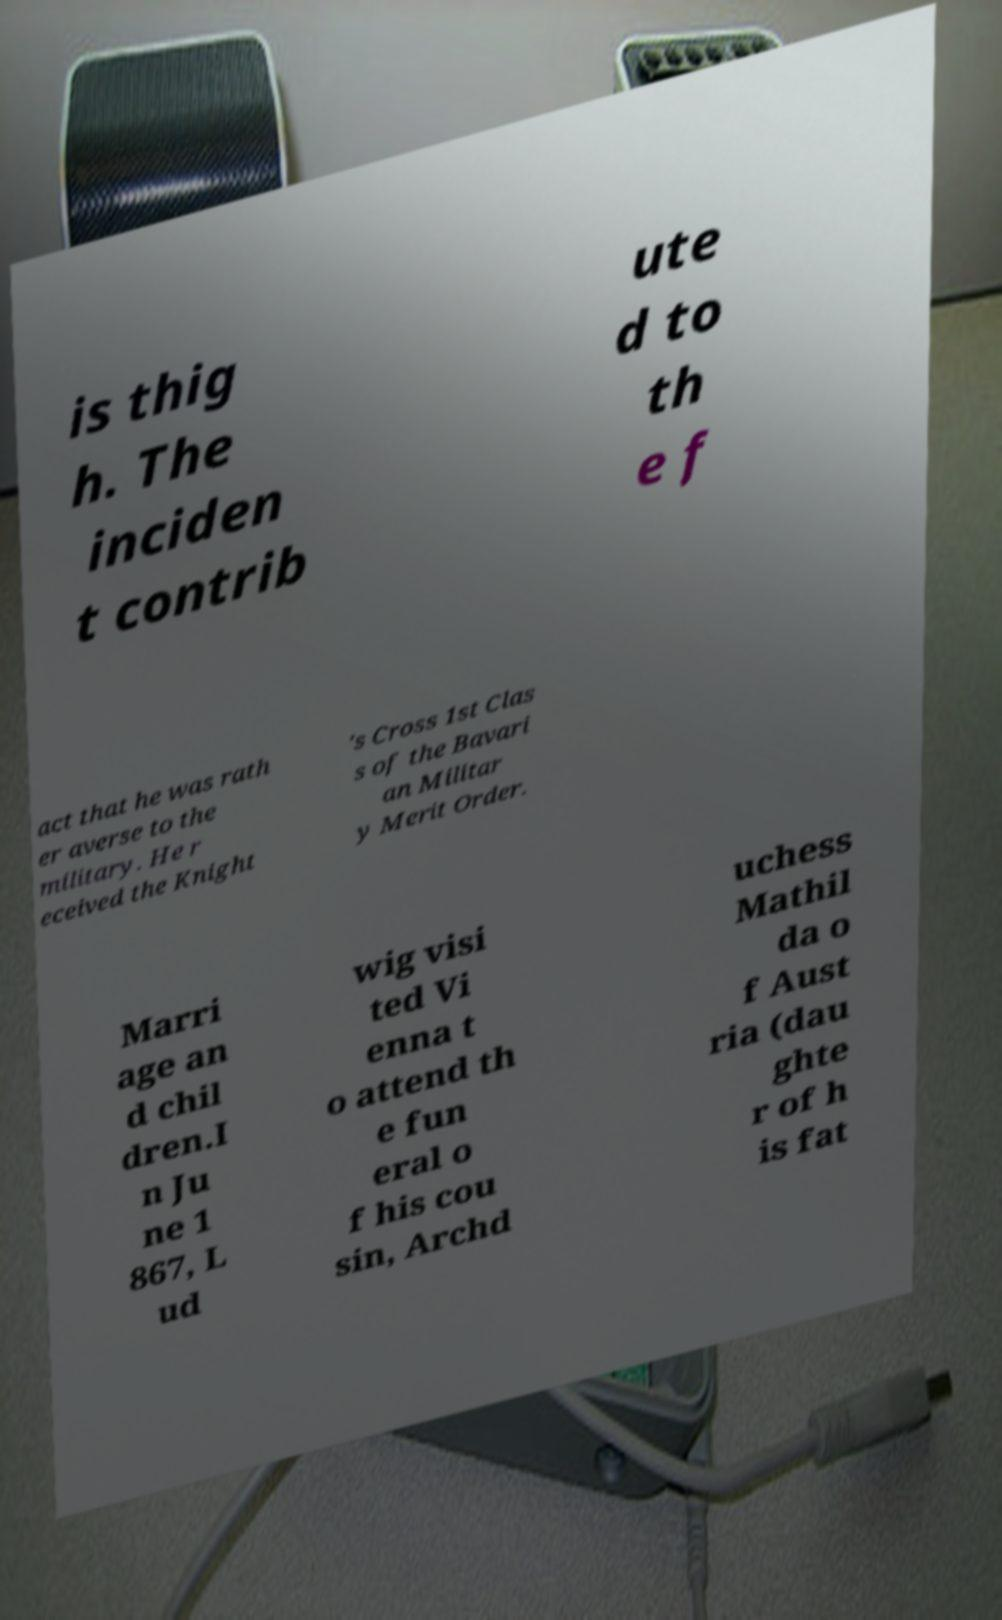Could you assist in decoding the text presented in this image and type it out clearly? is thig h. The inciden t contrib ute d to th e f act that he was rath er averse to the military. He r eceived the Knight 's Cross 1st Clas s of the Bavari an Militar y Merit Order. Marri age an d chil dren.I n Ju ne 1 867, L ud wig visi ted Vi enna t o attend th e fun eral o f his cou sin, Archd uchess Mathil da o f Aust ria (dau ghte r of h is fat 